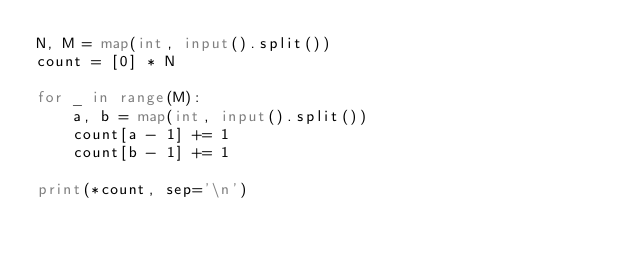Convert code to text. <code><loc_0><loc_0><loc_500><loc_500><_Python_>N, M = map(int, input().split())
count = [0] * N

for _ in range(M):
    a, b = map(int, input().split())
    count[a - 1] += 1
    count[b - 1] += 1

print(*count, sep='\n')</code> 